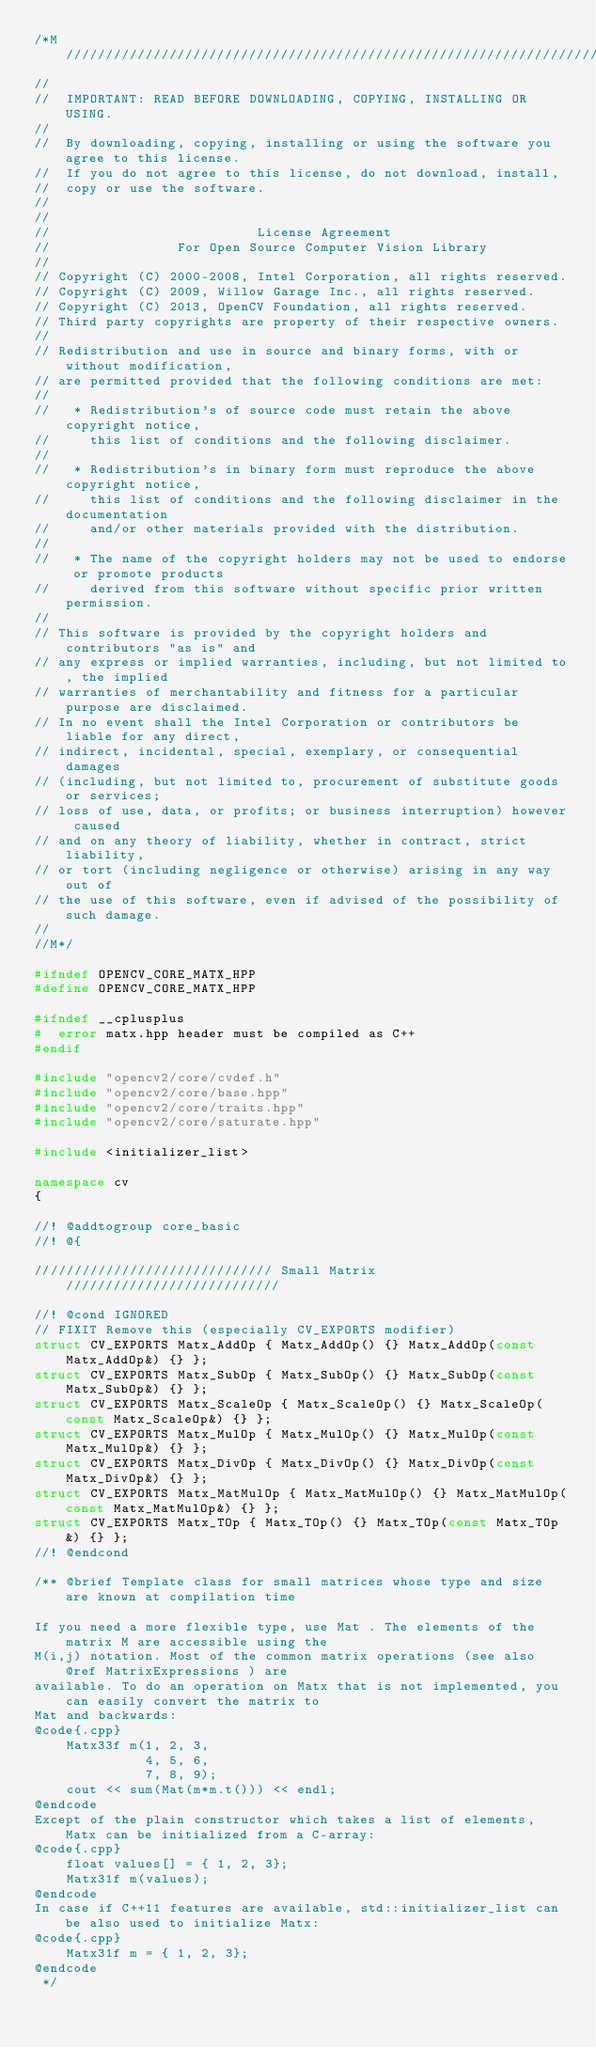Convert code to text. <code><loc_0><loc_0><loc_500><loc_500><_C++_>/*M///////////////////////////////////////////////////////////////////////////////////////
//
//  IMPORTANT: READ BEFORE DOWNLOADING, COPYING, INSTALLING OR USING.
//
//  By downloading, copying, installing or using the software you agree to this license.
//  If you do not agree to this license, do not download, install,
//  copy or use the software.
//
//
//                          License Agreement
//                For Open Source Computer Vision Library
//
// Copyright (C) 2000-2008, Intel Corporation, all rights reserved.
// Copyright (C) 2009, Willow Garage Inc., all rights reserved.
// Copyright (C) 2013, OpenCV Foundation, all rights reserved.
// Third party copyrights are property of their respective owners.
//
// Redistribution and use in source and binary forms, with or without modification,
// are permitted provided that the following conditions are met:
//
//   * Redistribution's of source code must retain the above copyright notice,
//     this list of conditions and the following disclaimer.
//
//   * Redistribution's in binary form must reproduce the above copyright notice,
//     this list of conditions and the following disclaimer in the documentation
//     and/or other materials provided with the distribution.
//
//   * The name of the copyright holders may not be used to endorse or promote products
//     derived from this software without specific prior written permission.
//
// This software is provided by the copyright holders and contributors "as is" and
// any express or implied warranties, including, but not limited to, the implied
// warranties of merchantability and fitness for a particular purpose are disclaimed.
// In no event shall the Intel Corporation or contributors be liable for any direct,
// indirect, incidental, special, exemplary, or consequential damages
// (including, but not limited to, procurement of substitute goods or services;
// loss of use, data, or profits; or business interruption) however caused
// and on any theory of liability, whether in contract, strict liability,
// or tort (including negligence or otherwise) arising in any way out of
// the use of this software, even if advised of the possibility of such damage.
//
//M*/

#ifndef OPENCV_CORE_MATX_HPP
#define OPENCV_CORE_MATX_HPP

#ifndef __cplusplus
#  error matx.hpp header must be compiled as C++
#endif

#include "opencv2/core/cvdef.h"
#include "opencv2/core/base.hpp"
#include "opencv2/core/traits.hpp"
#include "opencv2/core/saturate.hpp"

#include <initializer_list>

namespace cv
{

//! @addtogroup core_basic
//! @{

////////////////////////////// Small Matrix ///////////////////////////

//! @cond IGNORED
// FIXIT Remove this (especially CV_EXPORTS modifier)
struct CV_EXPORTS Matx_AddOp { Matx_AddOp() {} Matx_AddOp(const Matx_AddOp&) {} };
struct CV_EXPORTS Matx_SubOp { Matx_SubOp() {} Matx_SubOp(const Matx_SubOp&) {} };
struct CV_EXPORTS Matx_ScaleOp { Matx_ScaleOp() {} Matx_ScaleOp(const Matx_ScaleOp&) {} };
struct CV_EXPORTS Matx_MulOp { Matx_MulOp() {} Matx_MulOp(const Matx_MulOp&) {} };
struct CV_EXPORTS Matx_DivOp { Matx_DivOp() {} Matx_DivOp(const Matx_DivOp&) {} };
struct CV_EXPORTS Matx_MatMulOp { Matx_MatMulOp() {} Matx_MatMulOp(const Matx_MatMulOp&) {} };
struct CV_EXPORTS Matx_TOp { Matx_TOp() {} Matx_TOp(const Matx_TOp&) {} };
//! @endcond

/** @brief Template class for small matrices whose type and size are known at compilation time

If you need a more flexible type, use Mat . The elements of the matrix M are accessible using the
M(i,j) notation. Most of the common matrix operations (see also @ref MatrixExpressions ) are
available. To do an operation on Matx that is not implemented, you can easily convert the matrix to
Mat and backwards:
@code{.cpp}
    Matx33f m(1, 2, 3,
              4, 5, 6,
              7, 8, 9);
    cout << sum(Mat(m*m.t())) << endl;
@endcode
Except of the plain constructor which takes a list of elements, Matx can be initialized from a C-array:
@code{.cpp}
    float values[] = { 1, 2, 3};
    Matx31f m(values);
@endcode
In case if C++11 features are available, std::initializer_list can be also used to initialize Matx:
@code{.cpp}
    Matx31f m = { 1, 2, 3};
@endcode
 */</code> 